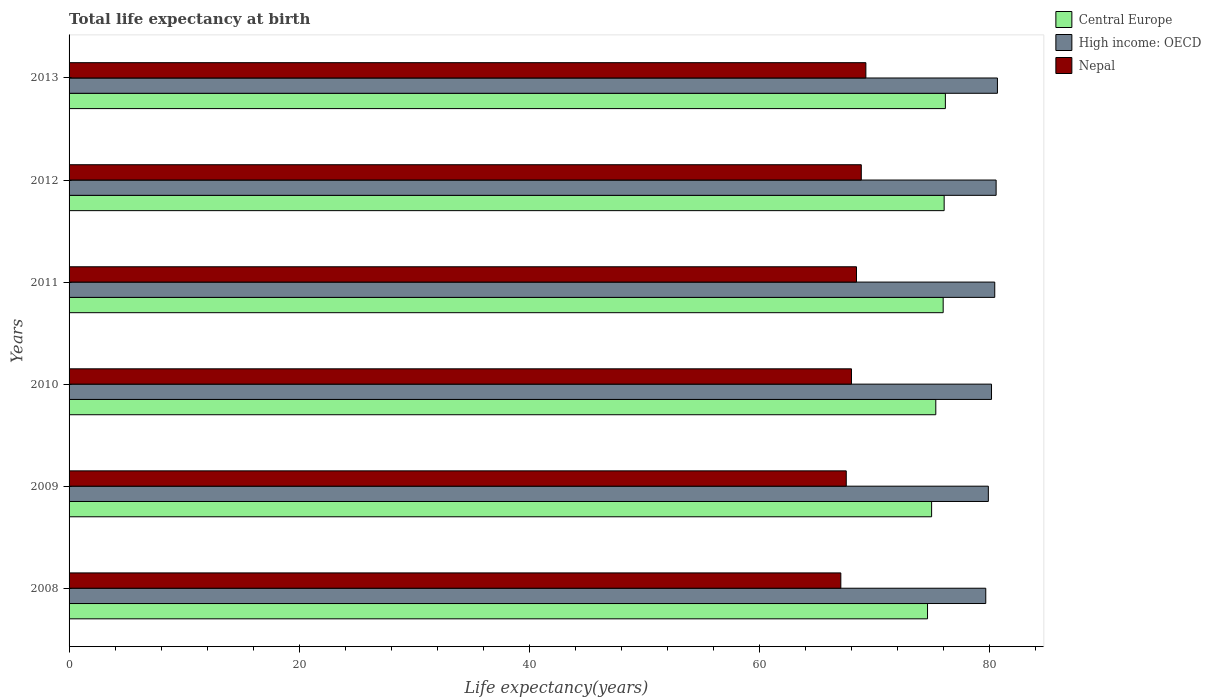How many groups of bars are there?
Offer a terse response. 6. Are the number of bars per tick equal to the number of legend labels?
Provide a succinct answer. Yes. Are the number of bars on each tick of the Y-axis equal?
Offer a very short reply. Yes. How many bars are there on the 6th tick from the top?
Your answer should be compact. 3. How many bars are there on the 2nd tick from the bottom?
Your response must be concise. 3. What is the label of the 3rd group of bars from the top?
Your response must be concise. 2011. What is the life expectancy at birth in in Nepal in 2009?
Your answer should be compact. 67.52. Across all years, what is the maximum life expectancy at birth in in Nepal?
Provide a succinct answer. 69.22. Across all years, what is the minimum life expectancy at birth in in High income: OECD?
Your answer should be compact. 79.64. In which year was the life expectancy at birth in in Central Europe maximum?
Offer a very short reply. 2013. In which year was the life expectancy at birth in in Central Europe minimum?
Your response must be concise. 2008. What is the total life expectancy at birth in in High income: OECD in the graph?
Offer a terse response. 481.24. What is the difference between the life expectancy at birth in in Central Europe in 2010 and that in 2012?
Provide a short and direct response. -0.73. What is the difference between the life expectancy at birth in in High income: OECD in 2009 and the life expectancy at birth in in Nepal in 2011?
Offer a very short reply. 11.45. What is the average life expectancy at birth in in Central Europe per year?
Keep it short and to the point. 75.48. In the year 2011, what is the difference between the life expectancy at birth in in High income: OECD and life expectancy at birth in in Central Europe?
Provide a short and direct response. 4.48. In how many years, is the life expectancy at birth in in Central Europe greater than 80 years?
Offer a very short reply. 0. What is the ratio of the life expectancy at birth in in Nepal in 2008 to that in 2012?
Provide a short and direct response. 0.97. Is the difference between the life expectancy at birth in in High income: OECD in 2008 and 2011 greater than the difference between the life expectancy at birth in in Central Europe in 2008 and 2011?
Make the answer very short. Yes. What is the difference between the highest and the second highest life expectancy at birth in in Nepal?
Ensure brevity in your answer.  0.4. What is the difference between the highest and the lowest life expectancy at birth in in Central Europe?
Make the answer very short. 1.55. In how many years, is the life expectancy at birth in in Central Europe greater than the average life expectancy at birth in in Central Europe taken over all years?
Your answer should be compact. 3. What does the 2nd bar from the top in 2009 represents?
Keep it short and to the point. High income: OECD. What does the 1st bar from the bottom in 2008 represents?
Your answer should be compact. Central Europe. Is it the case that in every year, the sum of the life expectancy at birth in in Central Europe and life expectancy at birth in in Nepal is greater than the life expectancy at birth in in High income: OECD?
Keep it short and to the point. Yes. How many bars are there?
Provide a short and direct response. 18. Are all the bars in the graph horizontal?
Give a very brief answer. Yes. How many years are there in the graph?
Keep it short and to the point. 6. Are the values on the major ticks of X-axis written in scientific E-notation?
Make the answer very short. No. Does the graph contain grids?
Your answer should be very brief. No. Where does the legend appear in the graph?
Offer a terse response. Top right. How many legend labels are there?
Your response must be concise. 3. What is the title of the graph?
Your response must be concise. Total life expectancy at birth. What is the label or title of the X-axis?
Ensure brevity in your answer.  Life expectancy(years). What is the Life expectancy(years) of Central Europe in 2008?
Provide a short and direct response. 74.58. What is the Life expectancy(years) of High income: OECD in 2008?
Offer a terse response. 79.64. What is the Life expectancy(years) of Nepal in 2008?
Provide a short and direct response. 67.05. What is the Life expectancy(years) in Central Europe in 2009?
Offer a very short reply. 74.93. What is the Life expectancy(years) in High income: OECD in 2009?
Provide a short and direct response. 79.86. What is the Life expectancy(years) of Nepal in 2009?
Provide a short and direct response. 67.52. What is the Life expectancy(years) of Central Europe in 2010?
Give a very brief answer. 75.3. What is the Life expectancy(years) in High income: OECD in 2010?
Provide a succinct answer. 80.14. What is the Life expectancy(years) of Nepal in 2010?
Your answer should be compact. 67.97. What is the Life expectancy(years) in Central Europe in 2011?
Make the answer very short. 75.94. What is the Life expectancy(years) of High income: OECD in 2011?
Your answer should be compact. 80.42. What is the Life expectancy(years) of Nepal in 2011?
Provide a short and direct response. 68.41. What is the Life expectancy(years) of Central Europe in 2012?
Your answer should be very brief. 76.02. What is the Life expectancy(years) of High income: OECD in 2012?
Provide a short and direct response. 80.54. What is the Life expectancy(years) in Nepal in 2012?
Ensure brevity in your answer.  68.82. What is the Life expectancy(years) in Central Europe in 2013?
Ensure brevity in your answer.  76.13. What is the Life expectancy(years) in High income: OECD in 2013?
Keep it short and to the point. 80.65. What is the Life expectancy(years) in Nepal in 2013?
Provide a short and direct response. 69.22. Across all years, what is the maximum Life expectancy(years) of Central Europe?
Ensure brevity in your answer.  76.13. Across all years, what is the maximum Life expectancy(years) of High income: OECD?
Your response must be concise. 80.65. Across all years, what is the maximum Life expectancy(years) in Nepal?
Make the answer very short. 69.22. Across all years, what is the minimum Life expectancy(years) in Central Europe?
Your answer should be compact. 74.58. Across all years, what is the minimum Life expectancy(years) of High income: OECD?
Provide a succinct answer. 79.64. Across all years, what is the minimum Life expectancy(years) in Nepal?
Make the answer very short. 67.05. What is the total Life expectancy(years) in Central Europe in the graph?
Offer a very short reply. 452.89. What is the total Life expectancy(years) of High income: OECD in the graph?
Offer a terse response. 481.24. What is the total Life expectancy(years) of Nepal in the graph?
Give a very brief answer. 408.99. What is the difference between the Life expectancy(years) of Central Europe in 2008 and that in 2009?
Keep it short and to the point. -0.35. What is the difference between the Life expectancy(years) of High income: OECD in 2008 and that in 2009?
Provide a succinct answer. -0.22. What is the difference between the Life expectancy(years) in Nepal in 2008 and that in 2009?
Make the answer very short. -0.47. What is the difference between the Life expectancy(years) of Central Europe in 2008 and that in 2010?
Make the answer very short. -0.72. What is the difference between the Life expectancy(years) of High income: OECD in 2008 and that in 2010?
Make the answer very short. -0.5. What is the difference between the Life expectancy(years) of Nepal in 2008 and that in 2010?
Ensure brevity in your answer.  -0.93. What is the difference between the Life expectancy(years) of Central Europe in 2008 and that in 2011?
Your answer should be compact. -1.36. What is the difference between the Life expectancy(years) in High income: OECD in 2008 and that in 2011?
Keep it short and to the point. -0.78. What is the difference between the Life expectancy(years) of Nepal in 2008 and that in 2011?
Provide a succinct answer. -1.36. What is the difference between the Life expectancy(years) of Central Europe in 2008 and that in 2012?
Make the answer very short. -1.44. What is the difference between the Life expectancy(years) in High income: OECD in 2008 and that in 2012?
Offer a very short reply. -0.9. What is the difference between the Life expectancy(years) of Nepal in 2008 and that in 2012?
Give a very brief answer. -1.78. What is the difference between the Life expectancy(years) in Central Europe in 2008 and that in 2013?
Offer a terse response. -1.55. What is the difference between the Life expectancy(years) of High income: OECD in 2008 and that in 2013?
Make the answer very short. -1.01. What is the difference between the Life expectancy(years) of Nepal in 2008 and that in 2013?
Provide a short and direct response. -2.18. What is the difference between the Life expectancy(years) of Central Europe in 2009 and that in 2010?
Give a very brief answer. -0.36. What is the difference between the Life expectancy(years) of High income: OECD in 2009 and that in 2010?
Keep it short and to the point. -0.28. What is the difference between the Life expectancy(years) in Nepal in 2009 and that in 2010?
Offer a very short reply. -0.45. What is the difference between the Life expectancy(years) of Central Europe in 2009 and that in 2011?
Your response must be concise. -1.01. What is the difference between the Life expectancy(years) of High income: OECD in 2009 and that in 2011?
Offer a very short reply. -0.56. What is the difference between the Life expectancy(years) in Nepal in 2009 and that in 2011?
Your response must be concise. -0.89. What is the difference between the Life expectancy(years) in Central Europe in 2009 and that in 2012?
Make the answer very short. -1.09. What is the difference between the Life expectancy(years) of High income: OECD in 2009 and that in 2012?
Keep it short and to the point. -0.68. What is the difference between the Life expectancy(years) of Nepal in 2009 and that in 2012?
Provide a short and direct response. -1.3. What is the difference between the Life expectancy(years) in Central Europe in 2009 and that in 2013?
Offer a very short reply. -1.2. What is the difference between the Life expectancy(years) of High income: OECD in 2009 and that in 2013?
Offer a terse response. -0.79. What is the difference between the Life expectancy(years) in Nepal in 2009 and that in 2013?
Provide a short and direct response. -1.7. What is the difference between the Life expectancy(years) in Central Europe in 2010 and that in 2011?
Your answer should be compact. -0.64. What is the difference between the Life expectancy(years) in High income: OECD in 2010 and that in 2011?
Your response must be concise. -0.28. What is the difference between the Life expectancy(years) of Nepal in 2010 and that in 2011?
Ensure brevity in your answer.  -0.44. What is the difference between the Life expectancy(years) of Central Europe in 2010 and that in 2012?
Your answer should be compact. -0.73. What is the difference between the Life expectancy(years) in High income: OECD in 2010 and that in 2012?
Offer a terse response. -0.4. What is the difference between the Life expectancy(years) of Nepal in 2010 and that in 2012?
Your answer should be very brief. -0.85. What is the difference between the Life expectancy(years) in Central Europe in 2010 and that in 2013?
Your answer should be very brief. -0.83. What is the difference between the Life expectancy(years) in High income: OECD in 2010 and that in 2013?
Provide a succinct answer. -0.51. What is the difference between the Life expectancy(years) of Nepal in 2010 and that in 2013?
Give a very brief answer. -1.25. What is the difference between the Life expectancy(years) in Central Europe in 2011 and that in 2012?
Provide a short and direct response. -0.09. What is the difference between the Life expectancy(years) of High income: OECD in 2011 and that in 2012?
Offer a very short reply. -0.12. What is the difference between the Life expectancy(years) of Nepal in 2011 and that in 2012?
Offer a terse response. -0.42. What is the difference between the Life expectancy(years) in Central Europe in 2011 and that in 2013?
Make the answer very short. -0.19. What is the difference between the Life expectancy(years) of High income: OECD in 2011 and that in 2013?
Your answer should be very brief. -0.23. What is the difference between the Life expectancy(years) in Nepal in 2011 and that in 2013?
Offer a very short reply. -0.82. What is the difference between the Life expectancy(years) in Central Europe in 2012 and that in 2013?
Make the answer very short. -0.11. What is the difference between the Life expectancy(years) in High income: OECD in 2012 and that in 2013?
Offer a terse response. -0.11. What is the difference between the Life expectancy(years) in Nepal in 2012 and that in 2013?
Ensure brevity in your answer.  -0.4. What is the difference between the Life expectancy(years) of Central Europe in 2008 and the Life expectancy(years) of High income: OECD in 2009?
Offer a terse response. -5.28. What is the difference between the Life expectancy(years) in Central Europe in 2008 and the Life expectancy(years) in Nepal in 2009?
Offer a terse response. 7.06. What is the difference between the Life expectancy(years) in High income: OECD in 2008 and the Life expectancy(years) in Nepal in 2009?
Offer a terse response. 12.12. What is the difference between the Life expectancy(years) in Central Europe in 2008 and the Life expectancy(years) in High income: OECD in 2010?
Your answer should be very brief. -5.56. What is the difference between the Life expectancy(years) of Central Europe in 2008 and the Life expectancy(years) of Nepal in 2010?
Your answer should be compact. 6.61. What is the difference between the Life expectancy(years) in High income: OECD in 2008 and the Life expectancy(years) in Nepal in 2010?
Offer a terse response. 11.67. What is the difference between the Life expectancy(years) in Central Europe in 2008 and the Life expectancy(years) in High income: OECD in 2011?
Provide a short and direct response. -5.84. What is the difference between the Life expectancy(years) of Central Europe in 2008 and the Life expectancy(years) of Nepal in 2011?
Offer a terse response. 6.17. What is the difference between the Life expectancy(years) in High income: OECD in 2008 and the Life expectancy(years) in Nepal in 2011?
Provide a succinct answer. 11.23. What is the difference between the Life expectancy(years) of Central Europe in 2008 and the Life expectancy(years) of High income: OECD in 2012?
Offer a terse response. -5.96. What is the difference between the Life expectancy(years) of Central Europe in 2008 and the Life expectancy(years) of Nepal in 2012?
Keep it short and to the point. 5.75. What is the difference between the Life expectancy(years) in High income: OECD in 2008 and the Life expectancy(years) in Nepal in 2012?
Your answer should be very brief. 10.81. What is the difference between the Life expectancy(years) in Central Europe in 2008 and the Life expectancy(years) in High income: OECD in 2013?
Provide a short and direct response. -6.07. What is the difference between the Life expectancy(years) in Central Europe in 2008 and the Life expectancy(years) in Nepal in 2013?
Provide a short and direct response. 5.36. What is the difference between the Life expectancy(years) in High income: OECD in 2008 and the Life expectancy(years) in Nepal in 2013?
Provide a succinct answer. 10.41. What is the difference between the Life expectancy(years) of Central Europe in 2009 and the Life expectancy(years) of High income: OECD in 2010?
Your response must be concise. -5.2. What is the difference between the Life expectancy(years) of Central Europe in 2009 and the Life expectancy(years) of Nepal in 2010?
Make the answer very short. 6.96. What is the difference between the Life expectancy(years) of High income: OECD in 2009 and the Life expectancy(years) of Nepal in 2010?
Provide a succinct answer. 11.89. What is the difference between the Life expectancy(years) in Central Europe in 2009 and the Life expectancy(years) in High income: OECD in 2011?
Your answer should be compact. -5.49. What is the difference between the Life expectancy(years) of Central Europe in 2009 and the Life expectancy(years) of Nepal in 2011?
Offer a very short reply. 6.53. What is the difference between the Life expectancy(years) of High income: OECD in 2009 and the Life expectancy(years) of Nepal in 2011?
Your response must be concise. 11.45. What is the difference between the Life expectancy(years) of Central Europe in 2009 and the Life expectancy(years) of High income: OECD in 2012?
Your answer should be compact. -5.61. What is the difference between the Life expectancy(years) of Central Europe in 2009 and the Life expectancy(years) of Nepal in 2012?
Your answer should be very brief. 6.11. What is the difference between the Life expectancy(years) in High income: OECD in 2009 and the Life expectancy(years) in Nepal in 2012?
Provide a short and direct response. 11.04. What is the difference between the Life expectancy(years) in Central Europe in 2009 and the Life expectancy(years) in High income: OECD in 2013?
Give a very brief answer. -5.72. What is the difference between the Life expectancy(years) of Central Europe in 2009 and the Life expectancy(years) of Nepal in 2013?
Offer a terse response. 5.71. What is the difference between the Life expectancy(years) of High income: OECD in 2009 and the Life expectancy(years) of Nepal in 2013?
Make the answer very short. 10.64. What is the difference between the Life expectancy(years) in Central Europe in 2010 and the Life expectancy(years) in High income: OECD in 2011?
Your response must be concise. -5.12. What is the difference between the Life expectancy(years) in Central Europe in 2010 and the Life expectancy(years) in Nepal in 2011?
Make the answer very short. 6.89. What is the difference between the Life expectancy(years) of High income: OECD in 2010 and the Life expectancy(years) of Nepal in 2011?
Your answer should be compact. 11.73. What is the difference between the Life expectancy(years) of Central Europe in 2010 and the Life expectancy(years) of High income: OECD in 2012?
Your answer should be very brief. -5.24. What is the difference between the Life expectancy(years) in Central Europe in 2010 and the Life expectancy(years) in Nepal in 2012?
Offer a terse response. 6.47. What is the difference between the Life expectancy(years) of High income: OECD in 2010 and the Life expectancy(years) of Nepal in 2012?
Ensure brevity in your answer.  11.31. What is the difference between the Life expectancy(years) in Central Europe in 2010 and the Life expectancy(years) in High income: OECD in 2013?
Ensure brevity in your answer.  -5.36. What is the difference between the Life expectancy(years) of Central Europe in 2010 and the Life expectancy(years) of Nepal in 2013?
Keep it short and to the point. 6.07. What is the difference between the Life expectancy(years) of High income: OECD in 2010 and the Life expectancy(years) of Nepal in 2013?
Provide a succinct answer. 10.91. What is the difference between the Life expectancy(years) in Central Europe in 2011 and the Life expectancy(years) in High income: OECD in 2012?
Offer a terse response. -4.6. What is the difference between the Life expectancy(years) in Central Europe in 2011 and the Life expectancy(years) in Nepal in 2012?
Provide a succinct answer. 7.11. What is the difference between the Life expectancy(years) of High income: OECD in 2011 and the Life expectancy(years) of Nepal in 2012?
Ensure brevity in your answer.  11.59. What is the difference between the Life expectancy(years) of Central Europe in 2011 and the Life expectancy(years) of High income: OECD in 2013?
Your answer should be very brief. -4.71. What is the difference between the Life expectancy(years) in Central Europe in 2011 and the Life expectancy(years) in Nepal in 2013?
Offer a very short reply. 6.71. What is the difference between the Life expectancy(years) in High income: OECD in 2011 and the Life expectancy(years) in Nepal in 2013?
Your answer should be very brief. 11.2. What is the difference between the Life expectancy(years) in Central Europe in 2012 and the Life expectancy(years) in High income: OECD in 2013?
Offer a terse response. -4.63. What is the difference between the Life expectancy(years) of Central Europe in 2012 and the Life expectancy(years) of Nepal in 2013?
Make the answer very short. 6.8. What is the difference between the Life expectancy(years) in High income: OECD in 2012 and the Life expectancy(years) in Nepal in 2013?
Your answer should be compact. 11.32. What is the average Life expectancy(years) in Central Europe per year?
Your answer should be very brief. 75.48. What is the average Life expectancy(years) in High income: OECD per year?
Make the answer very short. 80.21. What is the average Life expectancy(years) of Nepal per year?
Ensure brevity in your answer.  68.16. In the year 2008, what is the difference between the Life expectancy(years) of Central Europe and Life expectancy(years) of High income: OECD?
Provide a short and direct response. -5.06. In the year 2008, what is the difference between the Life expectancy(years) of Central Europe and Life expectancy(years) of Nepal?
Provide a succinct answer. 7.53. In the year 2008, what is the difference between the Life expectancy(years) of High income: OECD and Life expectancy(years) of Nepal?
Ensure brevity in your answer.  12.59. In the year 2009, what is the difference between the Life expectancy(years) in Central Europe and Life expectancy(years) in High income: OECD?
Ensure brevity in your answer.  -4.93. In the year 2009, what is the difference between the Life expectancy(years) of Central Europe and Life expectancy(years) of Nepal?
Give a very brief answer. 7.41. In the year 2009, what is the difference between the Life expectancy(years) in High income: OECD and Life expectancy(years) in Nepal?
Give a very brief answer. 12.34. In the year 2010, what is the difference between the Life expectancy(years) in Central Europe and Life expectancy(years) in High income: OECD?
Provide a short and direct response. -4.84. In the year 2010, what is the difference between the Life expectancy(years) in Central Europe and Life expectancy(years) in Nepal?
Your answer should be compact. 7.32. In the year 2010, what is the difference between the Life expectancy(years) of High income: OECD and Life expectancy(years) of Nepal?
Offer a very short reply. 12.16. In the year 2011, what is the difference between the Life expectancy(years) of Central Europe and Life expectancy(years) of High income: OECD?
Ensure brevity in your answer.  -4.48. In the year 2011, what is the difference between the Life expectancy(years) in Central Europe and Life expectancy(years) in Nepal?
Keep it short and to the point. 7.53. In the year 2011, what is the difference between the Life expectancy(years) in High income: OECD and Life expectancy(years) in Nepal?
Offer a terse response. 12.01. In the year 2012, what is the difference between the Life expectancy(years) of Central Europe and Life expectancy(years) of High income: OECD?
Your answer should be compact. -4.51. In the year 2012, what is the difference between the Life expectancy(years) of Central Europe and Life expectancy(years) of Nepal?
Offer a very short reply. 7.2. In the year 2012, what is the difference between the Life expectancy(years) in High income: OECD and Life expectancy(years) in Nepal?
Make the answer very short. 11.71. In the year 2013, what is the difference between the Life expectancy(years) of Central Europe and Life expectancy(years) of High income: OECD?
Your answer should be very brief. -4.52. In the year 2013, what is the difference between the Life expectancy(years) in Central Europe and Life expectancy(years) in Nepal?
Your answer should be compact. 6.91. In the year 2013, what is the difference between the Life expectancy(years) in High income: OECD and Life expectancy(years) in Nepal?
Ensure brevity in your answer.  11.43. What is the ratio of the Life expectancy(years) of Nepal in 2008 to that in 2009?
Ensure brevity in your answer.  0.99. What is the ratio of the Life expectancy(years) in Nepal in 2008 to that in 2010?
Your response must be concise. 0.99. What is the ratio of the Life expectancy(years) of Central Europe in 2008 to that in 2011?
Keep it short and to the point. 0.98. What is the ratio of the Life expectancy(years) of High income: OECD in 2008 to that in 2011?
Offer a terse response. 0.99. What is the ratio of the Life expectancy(years) in Nepal in 2008 to that in 2011?
Provide a short and direct response. 0.98. What is the ratio of the Life expectancy(years) in High income: OECD in 2008 to that in 2012?
Your answer should be very brief. 0.99. What is the ratio of the Life expectancy(years) of Nepal in 2008 to that in 2012?
Provide a succinct answer. 0.97. What is the ratio of the Life expectancy(years) in Central Europe in 2008 to that in 2013?
Provide a short and direct response. 0.98. What is the ratio of the Life expectancy(years) in High income: OECD in 2008 to that in 2013?
Make the answer very short. 0.99. What is the ratio of the Life expectancy(years) of Nepal in 2008 to that in 2013?
Ensure brevity in your answer.  0.97. What is the ratio of the Life expectancy(years) in Central Europe in 2009 to that in 2010?
Provide a short and direct response. 1. What is the ratio of the Life expectancy(years) of High income: OECD in 2009 to that in 2010?
Ensure brevity in your answer.  1. What is the ratio of the Life expectancy(years) in Nepal in 2009 to that in 2010?
Ensure brevity in your answer.  0.99. What is the ratio of the Life expectancy(years) of Central Europe in 2009 to that in 2011?
Your answer should be very brief. 0.99. What is the ratio of the Life expectancy(years) of Central Europe in 2009 to that in 2012?
Make the answer very short. 0.99. What is the ratio of the Life expectancy(years) in High income: OECD in 2009 to that in 2012?
Offer a very short reply. 0.99. What is the ratio of the Life expectancy(years) of Central Europe in 2009 to that in 2013?
Offer a terse response. 0.98. What is the ratio of the Life expectancy(years) of High income: OECD in 2009 to that in 2013?
Your answer should be very brief. 0.99. What is the ratio of the Life expectancy(years) in Nepal in 2009 to that in 2013?
Keep it short and to the point. 0.98. What is the ratio of the Life expectancy(years) in Nepal in 2010 to that in 2011?
Your response must be concise. 0.99. What is the ratio of the Life expectancy(years) in Nepal in 2010 to that in 2012?
Offer a very short reply. 0.99. What is the ratio of the Life expectancy(years) of Central Europe in 2010 to that in 2013?
Your answer should be compact. 0.99. What is the ratio of the Life expectancy(years) of Nepal in 2010 to that in 2013?
Give a very brief answer. 0.98. What is the ratio of the Life expectancy(years) in Central Europe in 2011 to that in 2012?
Provide a succinct answer. 1. What is the ratio of the Life expectancy(years) of Nepal in 2011 to that in 2012?
Your answer should be compact. 0.99. What is the ratio of the Life expectancy(years) in Central Europe in 2012 to that in 2013?
Provide a short and direct response. 1. What is the ratio of the Life expectancy(years) of High income: OECD in 2012 to that in 2013?
Ensure brevity in your answer.  1. What is the difference between the highest and the second highest Life expectancy(years) in Central Europe?
Ensure brevity in your answer.  0.11. What is the difference between the highest and the second highest Life expectancy(years) in High income: OECD?
Give a very brief answer. 0.11. What is the difference between the highest and the second highest Life expectancy(years) of Nepal?
Your response must be concise. 0.4. What is the difference between the highest and the lowest Life expectancy(years) of Central Europe?
Offer a very short reply. 1.55. What is the difference between the highest and the lowest Life expectancy(years) in High income: OECD?
Offer a terse response. 1.01. What is the difference between the highest and the lowest Life expectancy(years) of Nepal?
Your response must be concise. 2.18. 